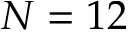Convert formula to latex. <formula><loc_0><loc_0><loc_500><loc_500>N = 1 2</formula> 